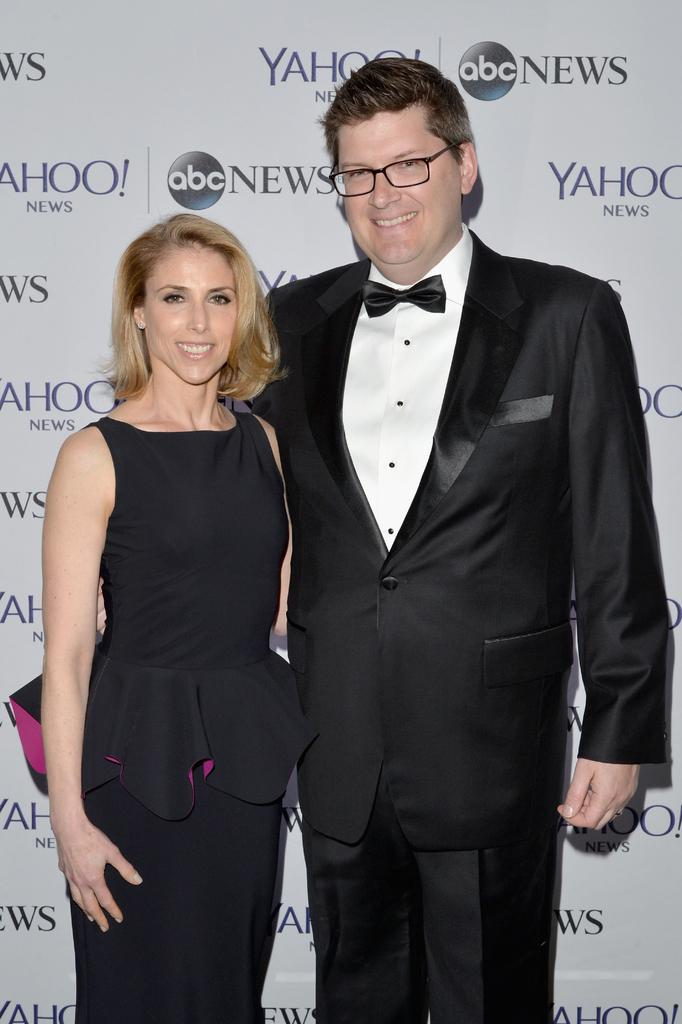Provide a one-sentence caption for the provided image. woman in a dress and a man in a suit stand in front of a yahoo and abc news advertisement. 